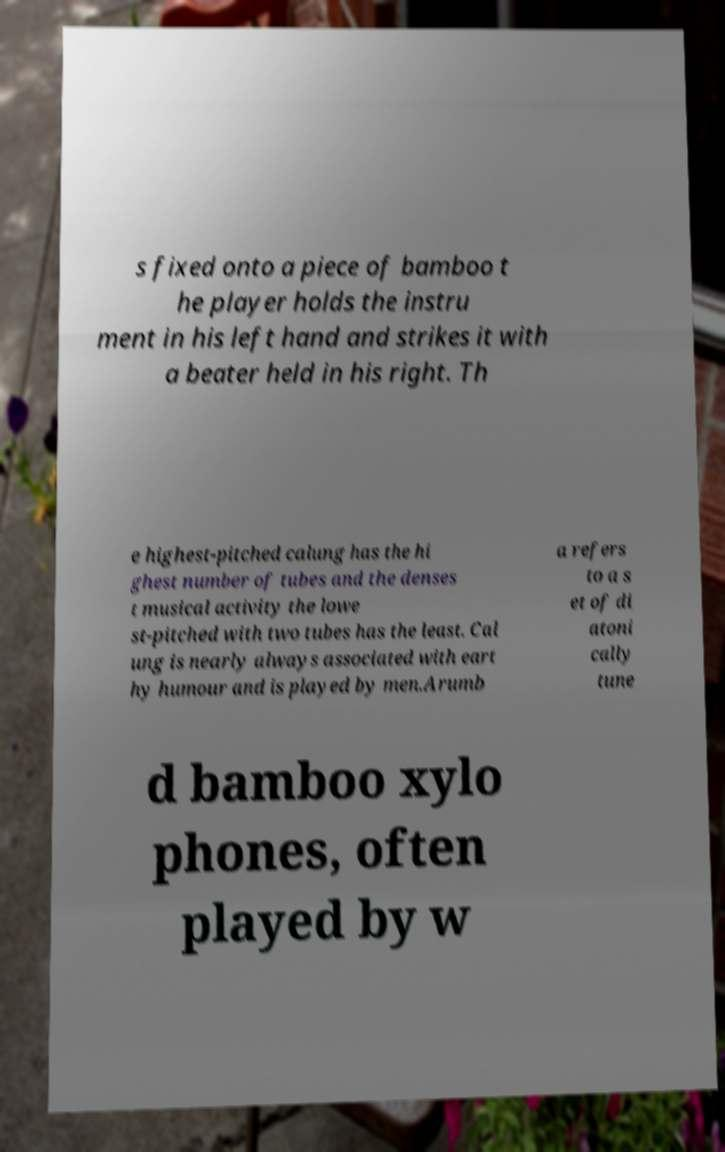Can you accurately transcribe the text from the provided image for me? s fixed onto a piece of bamboo t he player holds the instru ment in his left hand and strikes it with a beater held in his right. Th e highest-pitched calung has the hi ghest number of tubes and the denses t musical activity the lowe st-pitched with two tubes has the least. Cal ung is nearly always associated with eart hy humour and is played by men.Arumb a refers to a s et of di atoni cally tune d bamboo xylo phones, often played by w 